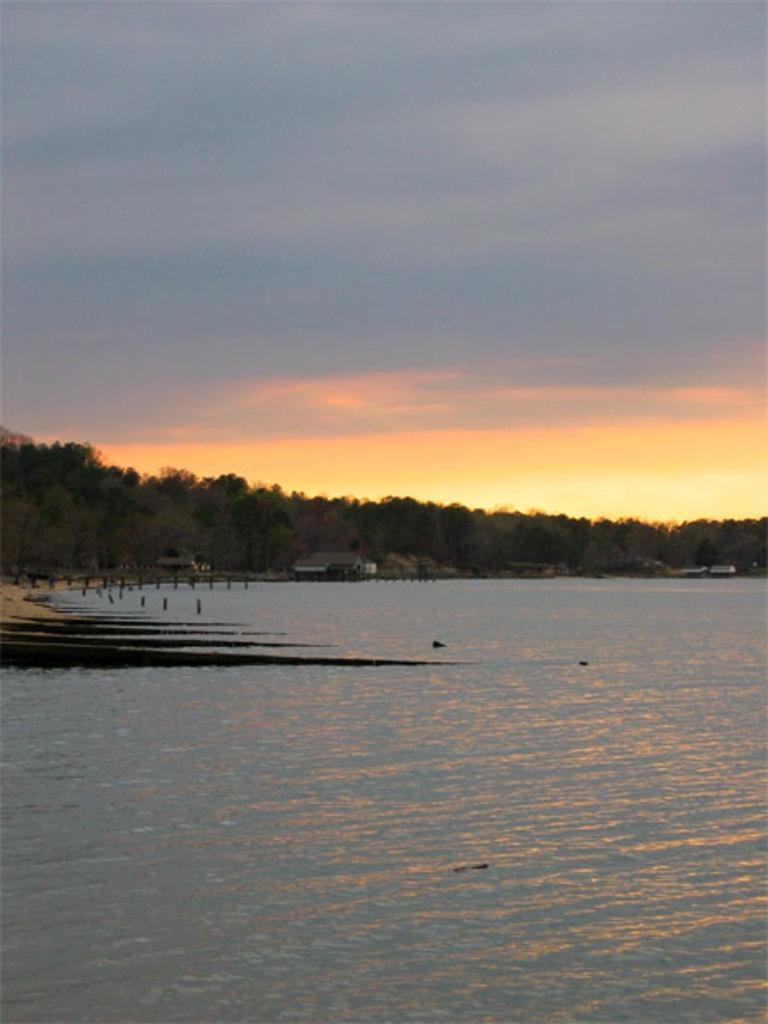Please provide a concise description of this image. In this image in the foreground is the water in the middle there are so many trees and in the background there is the sky. 